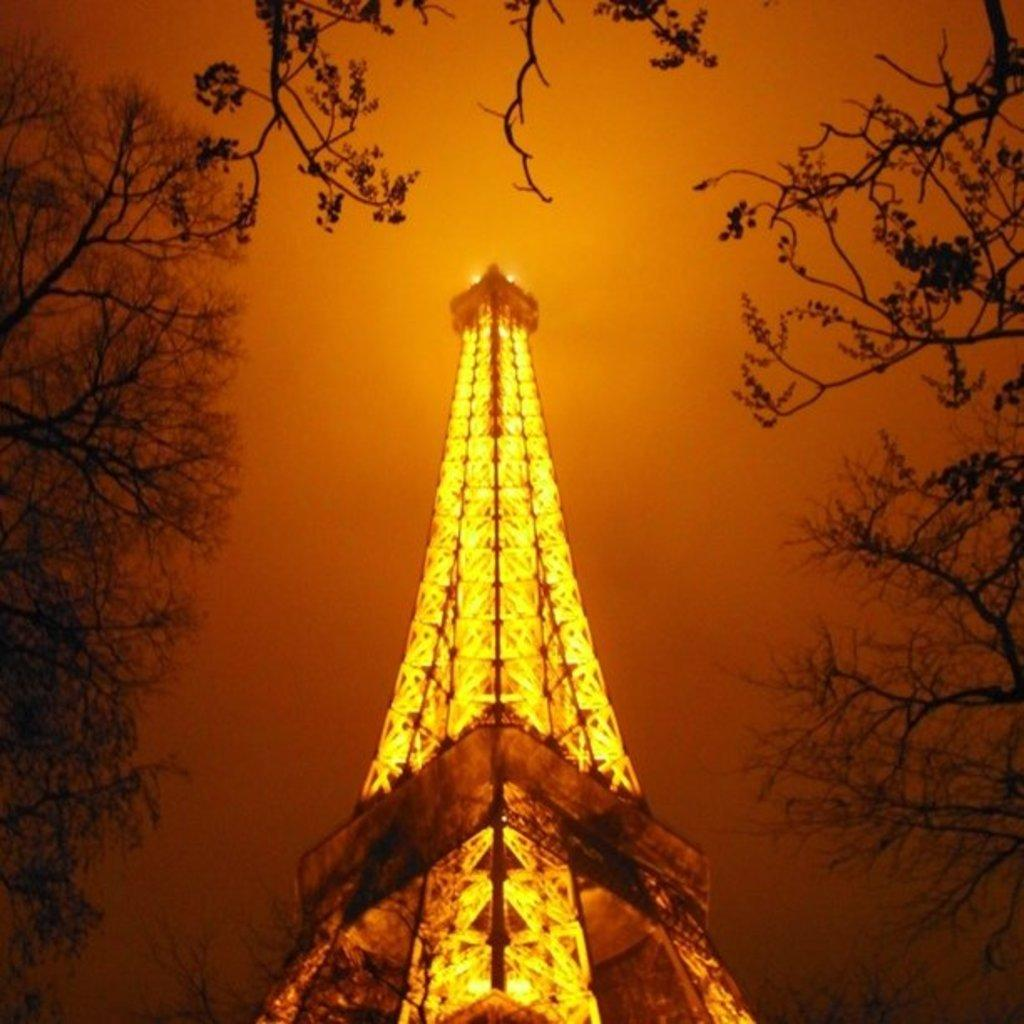What is the main structure in the image? There is a tower in the image. What color are the lights visible in the image? The lights in the image are yellow. What type of vegetation can be seen in the background of the image? There are trees in the background of the image. What part of the natural environment is visible in the image? The sky is visible in the background of the image. Where is the rake being used in the image? There is no rake present in the image. What type of cap is the person wearing in the image? There is no person or cap visible in the image. 